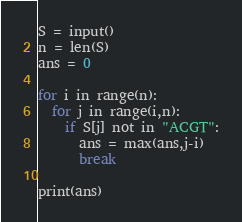<code> <loc_0><loc_0><loc_500><loc_500><_Python_>S = input()
n = len(S)
ans = 0

for i in range(n):
  for j in range(i,n):
    if S[j] not in "ACGT":
      ans = max(ans,j-i)
      break
      
print(ans)</code> 